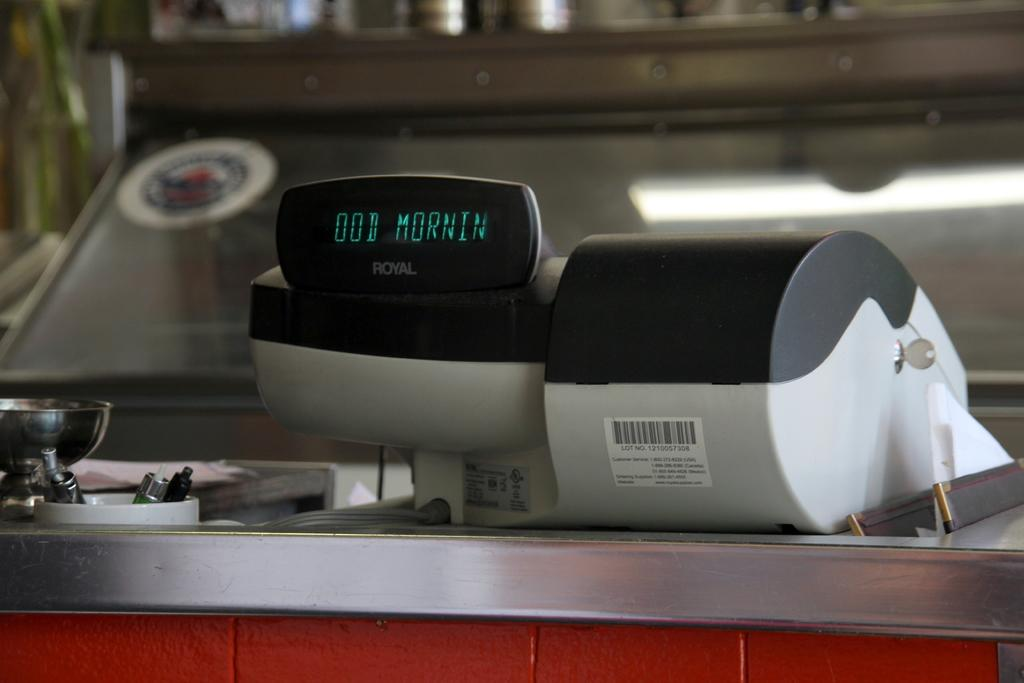<image>
Describe the image concisely. a royal device has the letters ood morning on the screen 